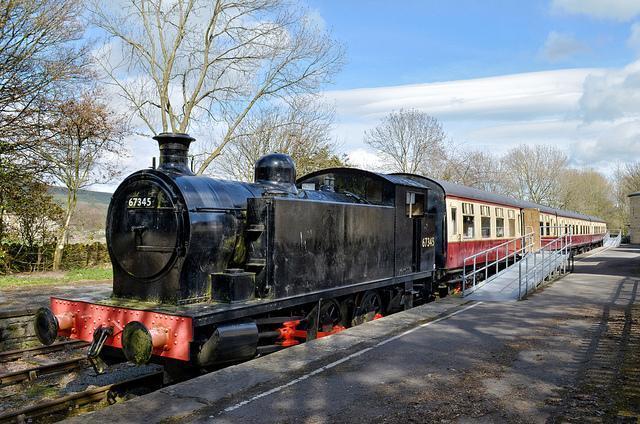How many trains are visible?
Give a very brief answer. 1. 